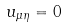<formula> <loc_0><loc_0><loc_500><loc_500>u _ { \mu \eta } = 0</formula> 